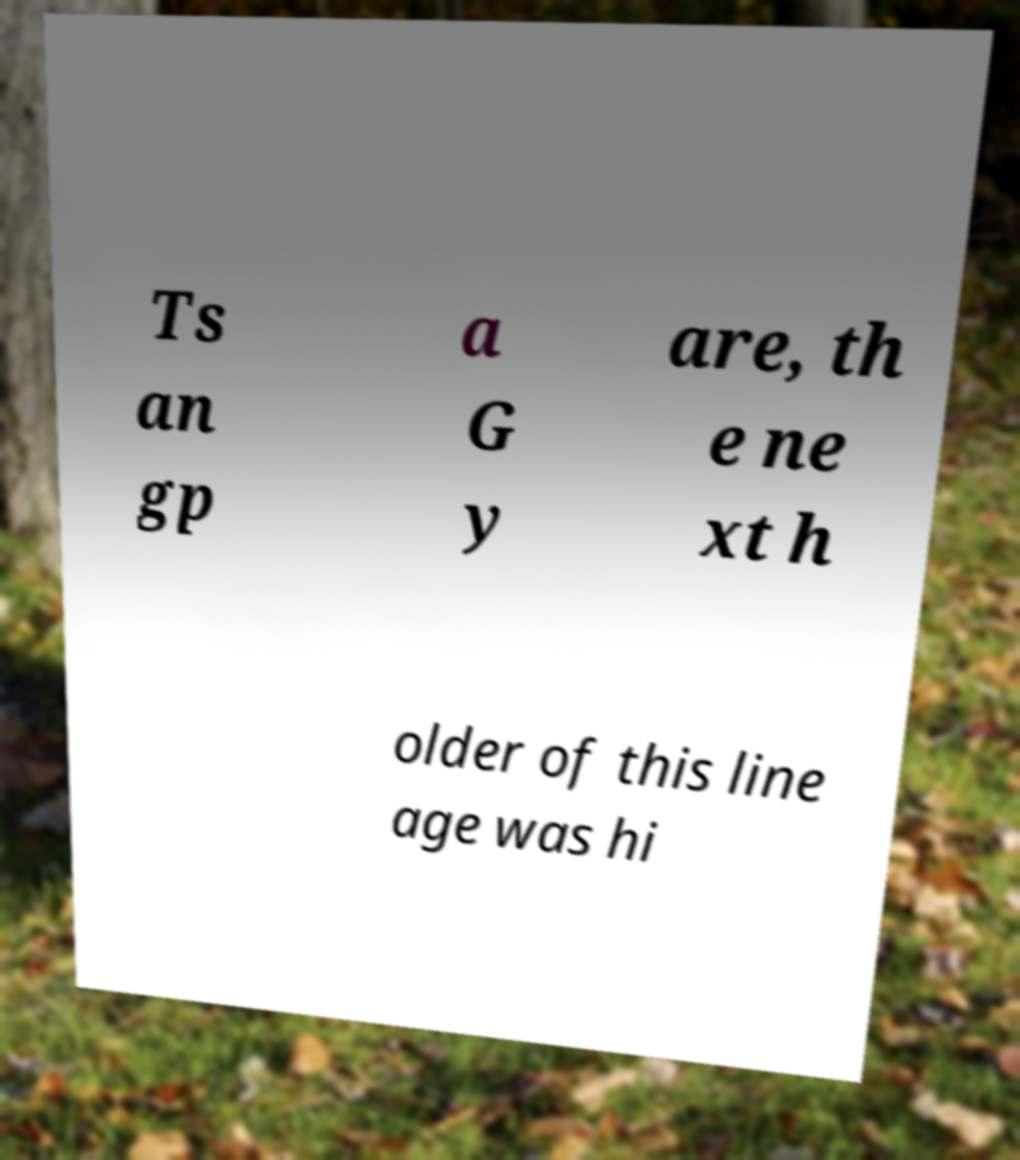Can you accurately transcribe the text from the provided image for me? Ts an gp a G y are, th e ne xt h older of this line age was hi 